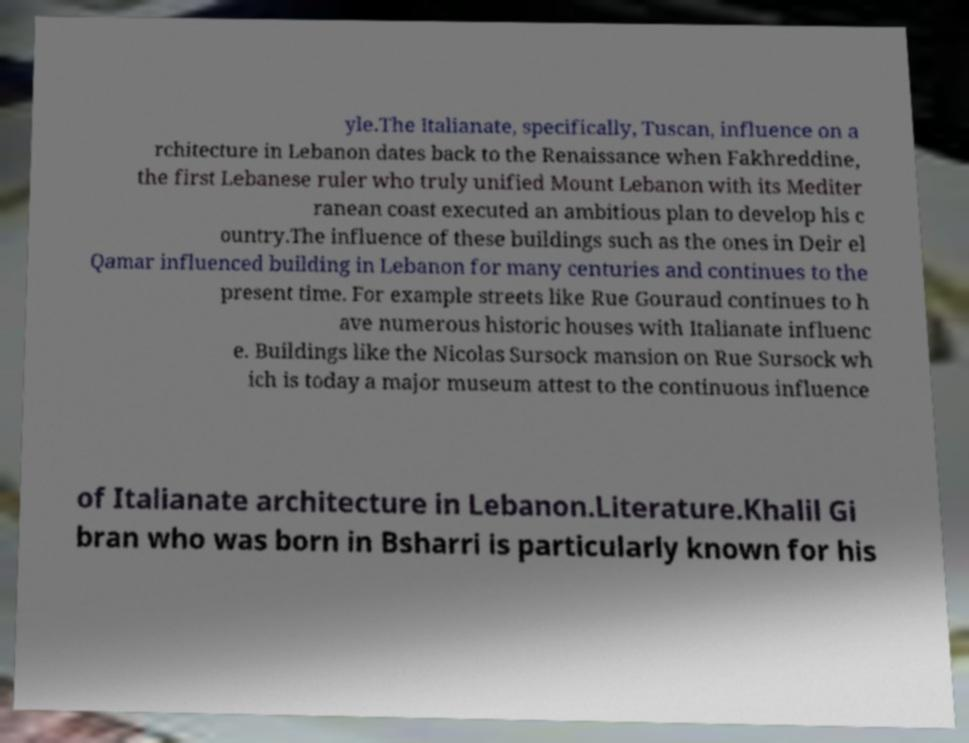What messages or text are displayed in this image? I need them in a readable, typed format. yle.The Italianate, specifically, Tuscan, influence on a rchitecture in Lebanon dates back to the Renaissance when Fakhreddine, the first Lebanese ruler who truly unified Mount Lebanon with its Mediter ranean coast executed an ambitious plan to develop his c ountry.The influence of these buildings such as the ones in Deir el Qamar influenced building in Lebanon for many centuries and continues to the present time. For example streets like Rue Gouraud continues to h ave numerous historic houses with Italianate influenc e. Buildings like the Nicolas Sursock mansion on Rue Sursock wh ich is today a major museum attest to the continuous influence of Italianate architecture in Lebanon.Literature.Khalil Gi bran who was born in Bsharri is particularly known for his 